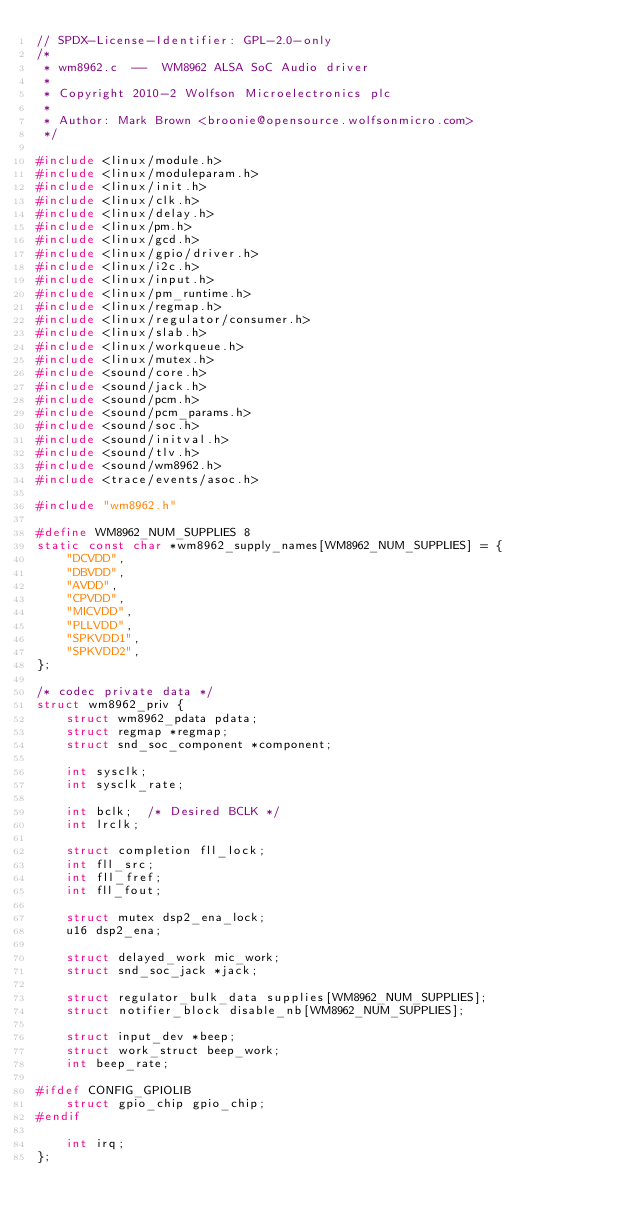<code> <loc_0><loc_0><loc_500><loc_500><_C_>// SPDX-License-Identifier: GPL-2.0-only
/*
 * wm8962.c  --  WM8962 ALSA SoC Audio driver
 *
 * Copyright 2010-2 Wolfson Microelectronics plc
 *
 * Author: Mark Brown <broonie@opensource.wolfsonmicro.com>
 */

#include <linux/module.h>
#include <linux/moduleparam.h>
#include <linux/init.h>
#include <linux/clk.h>
#include <linux/delay.h>
#include <linux/pm.h>
#include <linux/gcd.h>
#include <linux/gpio/driver.h>
#include <linux/i2c.h>
#include <linux/input.h>
#include <linux/pm_runtime.h>
#include <linux/regmap.h>
#include <linux/regulator/consumer.h>
#include <linux/slab.h>
#include <linux/workqueue.h>
#include <linux/mutex.h>
#include <sound/core.h>
#include <sound/jack.h>
#include <sound/pcm.h>
#include <sound/pcm_params.h>
#include <sound/soc.h>
#include <sound/initval.h>
#include <sound/tlv.h>
#include <sound/wm8962.h>
#include <trace/events/asoc.h>

#include "wm8962.h"

#define WM8962_NUM_SUPPLIES 8
static const char *wm8962_supply_names[WM8962_NUM_SUPPLIES] = {
	"DCVDD",
	"DBVDD",
	"AVDD",
	"CPVDD",
	"MICVDD",
	"PLLVDD",
	"SPKVDD1",
	"SPKVDD2",
};

/* codec private data */
struct wm8962_priv {
	struct wm8962_pdata pdata;
	struct regmap *regmap;
	struct snd_soc_component *component;

	int sysclk;
	int sysclk_rate;

	int bclk;  /* Desired BCLK */
	int lrclk;

	struct completion fll_lock;
	int fll_src;
	int fll_fref;
	int fll_fout;

	struct mutex dsp2_ena_lock;
	u16 dsp2_ena;

	struct delayed_work mic_work;
	struct snd_soc_jack *jack;

	struct regulator_bulk_data supplies[WM8962_NUM_SUPPLIES];
	struct notifier_block disable_nb[WM8962_NUM_SUPPLIES];

	struct input_dev *beep;
	struct work_struct beep_work;
	int beep_rate;

#ifdef CONFIG_GPIOLIB
	struct gpio_chip gpio_chip;
#endif

	int irq;
};
</code> 